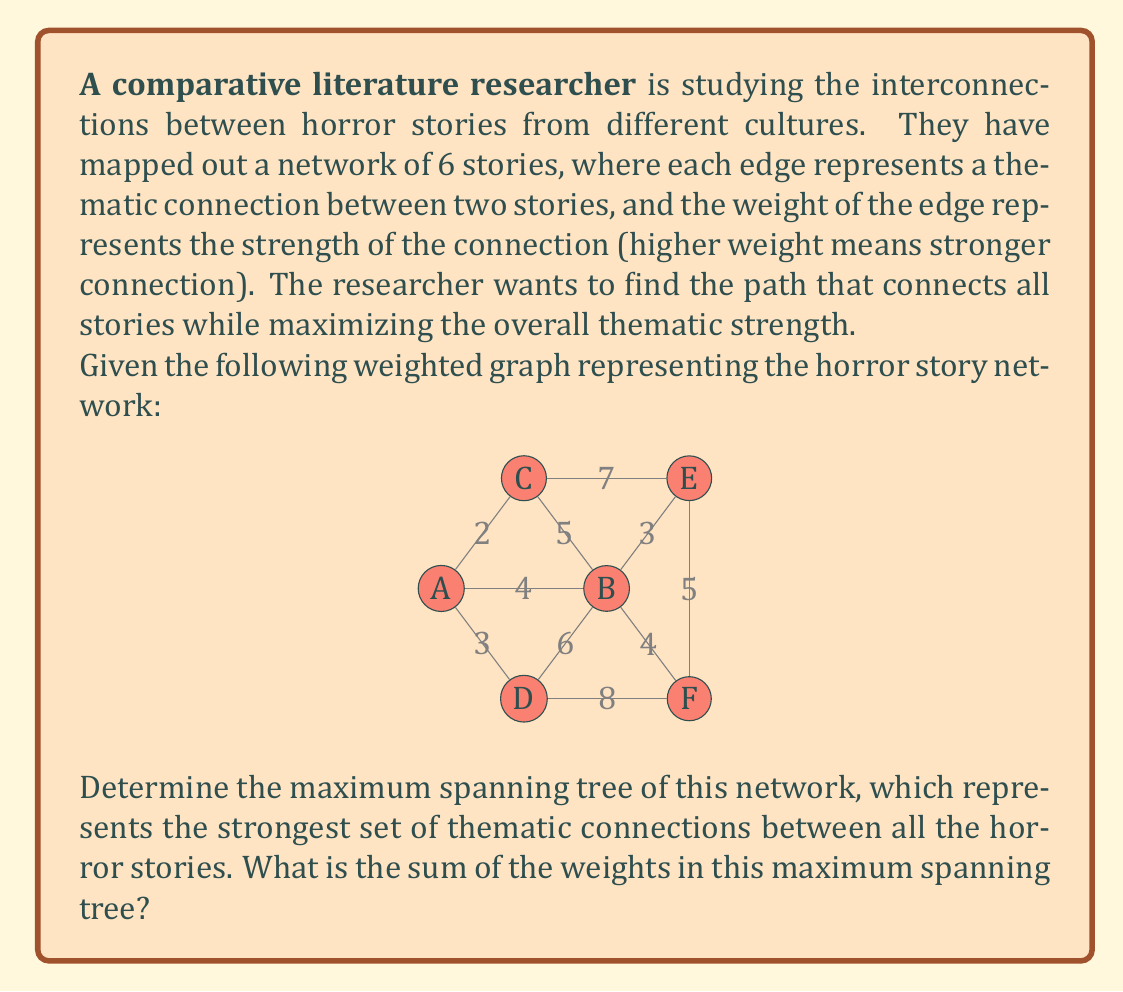Teach me how to tackle this problem. To solve this problem, we need to find the maximum spanning tree of the given graph. This is similar to finding the minimum spanning tree, but instead of choosing the edges with the smallest weights, we choose the edges with the largest weights.

We can use Kruskal's algorithm, but modified to select the largest weight edges instead of the smallest:

1. Sort all edges in descending order of their weight.
2. Pick the edge with the largest weight that doesn't form a cycle with the edges already selected.
3. Repeat step 2 until we have $n-1$ edges, where $n$ is the number of vertices.

Let's apply this algorithm to our graph:

Sorted edges (descending order):
1. D-F: 8
2. C-E: 7
3. B-D: 6
4. B-C: 5
5. E-F: 5
6. A-B: 4
7. B-F: 4
8. B-E: 3
9. A-D: 3
10. A-C: 2

Now, let's select edges:

1. Select D-F (8)
2. Select C-E (7)
3. Select B-D (6)
4. Select B-C (5)
5. Select A-B (4)

We stop here because we have selected 5 edges, which is enough to connect all 6 vertices without forming a cycle.

The maximum spanning tree is:
$$\{(D,F), (C,E), (B,D), (B,C), (A,B)\}$$

To find the sum of the weights, we add up the weights of these edges:
$$8 + 7 + 6 + 5 + 4 = 30$$
Answer: The sum of the weights in the maximum spanning tree is 30. 